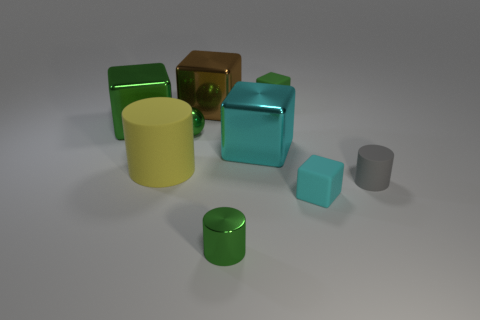Subtract all tiny rubber cylinders. How many cylinders are left? 2 Subtract all brown blocks. How many blocks are left? 4 Add 1 large shiny things. How many objects exist? 10 Subtract all balls. How many objects are left? 8 Subtract all gray cylinders. How many red cubes are left? 0 Subtract all large blue rubber cylinders. Subtract all green metallic blocks. How many objects are left? 8 Add 6 big green cubes. How many big green cubes are left? 7 Add 3 balls. How many balls exist? 4 Subtract 0 cyan cylinders. How many objects are left? 9 Subtract 2 cylinders. How many cylinders are left? 1 